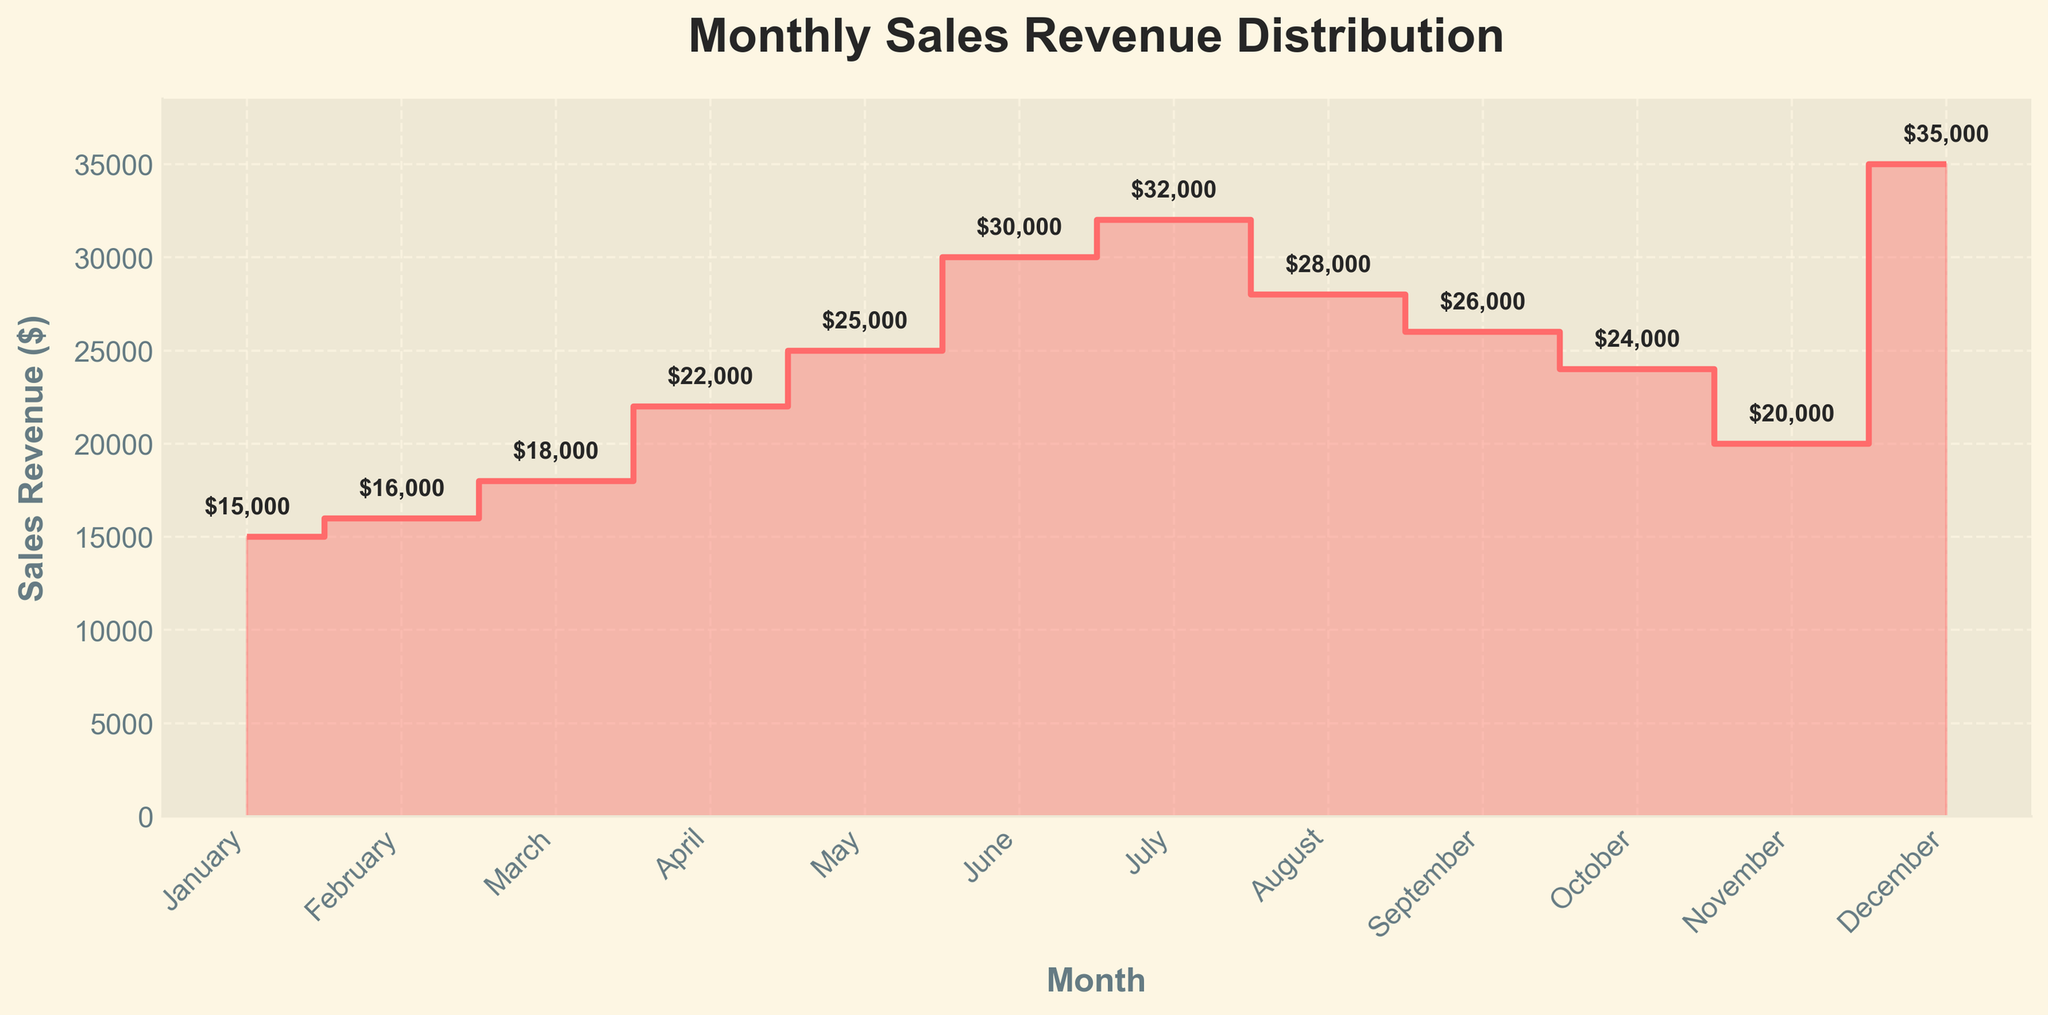What is the title of the chart? The title of the chart is a text label located at the top of the figure, specifying what the chart represents.
Answer: Monthly Sales Revenue Distribution How many months are represented in the chart? Count the number of data points along the x-axis labeled with month names.
Answer: 12 Which month has the highest sales revenue? Identify the highest point on the y-axis and find the corresponding x-axis label.
Answer: December What is the sales revenue in May? Locate the label "May" on the x-axis and look directly above to find the corresponding y-axis value.
Answer: $25,000 What is the average monthly sales revenue? Sum the sales revenues for all 12 months and divide by 12. Calculation: (15000 + 16000 + 18000 + 22000 + 25000 + 30000 + 32000 + 28000 + 26000 + 24000 + 20000 + 35000) / 12
Answer: $24,083.33 What is the sales revenue difference between June and July? Find the sales revenues for June and July, then subtract the value of June from that of July. Calculation: 32000 - 30000
Answer: $2000 During which seasons do the sales revenues peak? Identify the months with the highest sales revenues and correlate them with their respective seasons. E.g., December (Winter), June, July (Summer).
Answer: Winter and Summer By how much did the sales revenue increase from February to March? Subtract the sales revenue of February from that of March. Calculation: 18000 - 16000
Answer: $2000 What are the months where sales revenue drops compared to the previous month? Compare the sales revenue of each month to the following month and identify months where the revenue is lower in the following month.
Answer: August and September How much did the sales revenue collectively increase in the first half of the year compared to the second half? Sum the sales revenues from January to June and compare it with the sum from July to December. Calculation: First half: 15000 + 16000 + 18000 + 22000 + 25000 + 30000 = 126000; Second half: 32000 + 28000 + 26000 + 24000 + 20000 + 35000 = 165000; Difference: 165000 - 126000
Answer: $39,000 